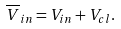<formula> <loc_0><loc_0><loc_500><loc_500>\overline { V } _ { i n } = V _ { i n } + V _ { c l } .</formula> 